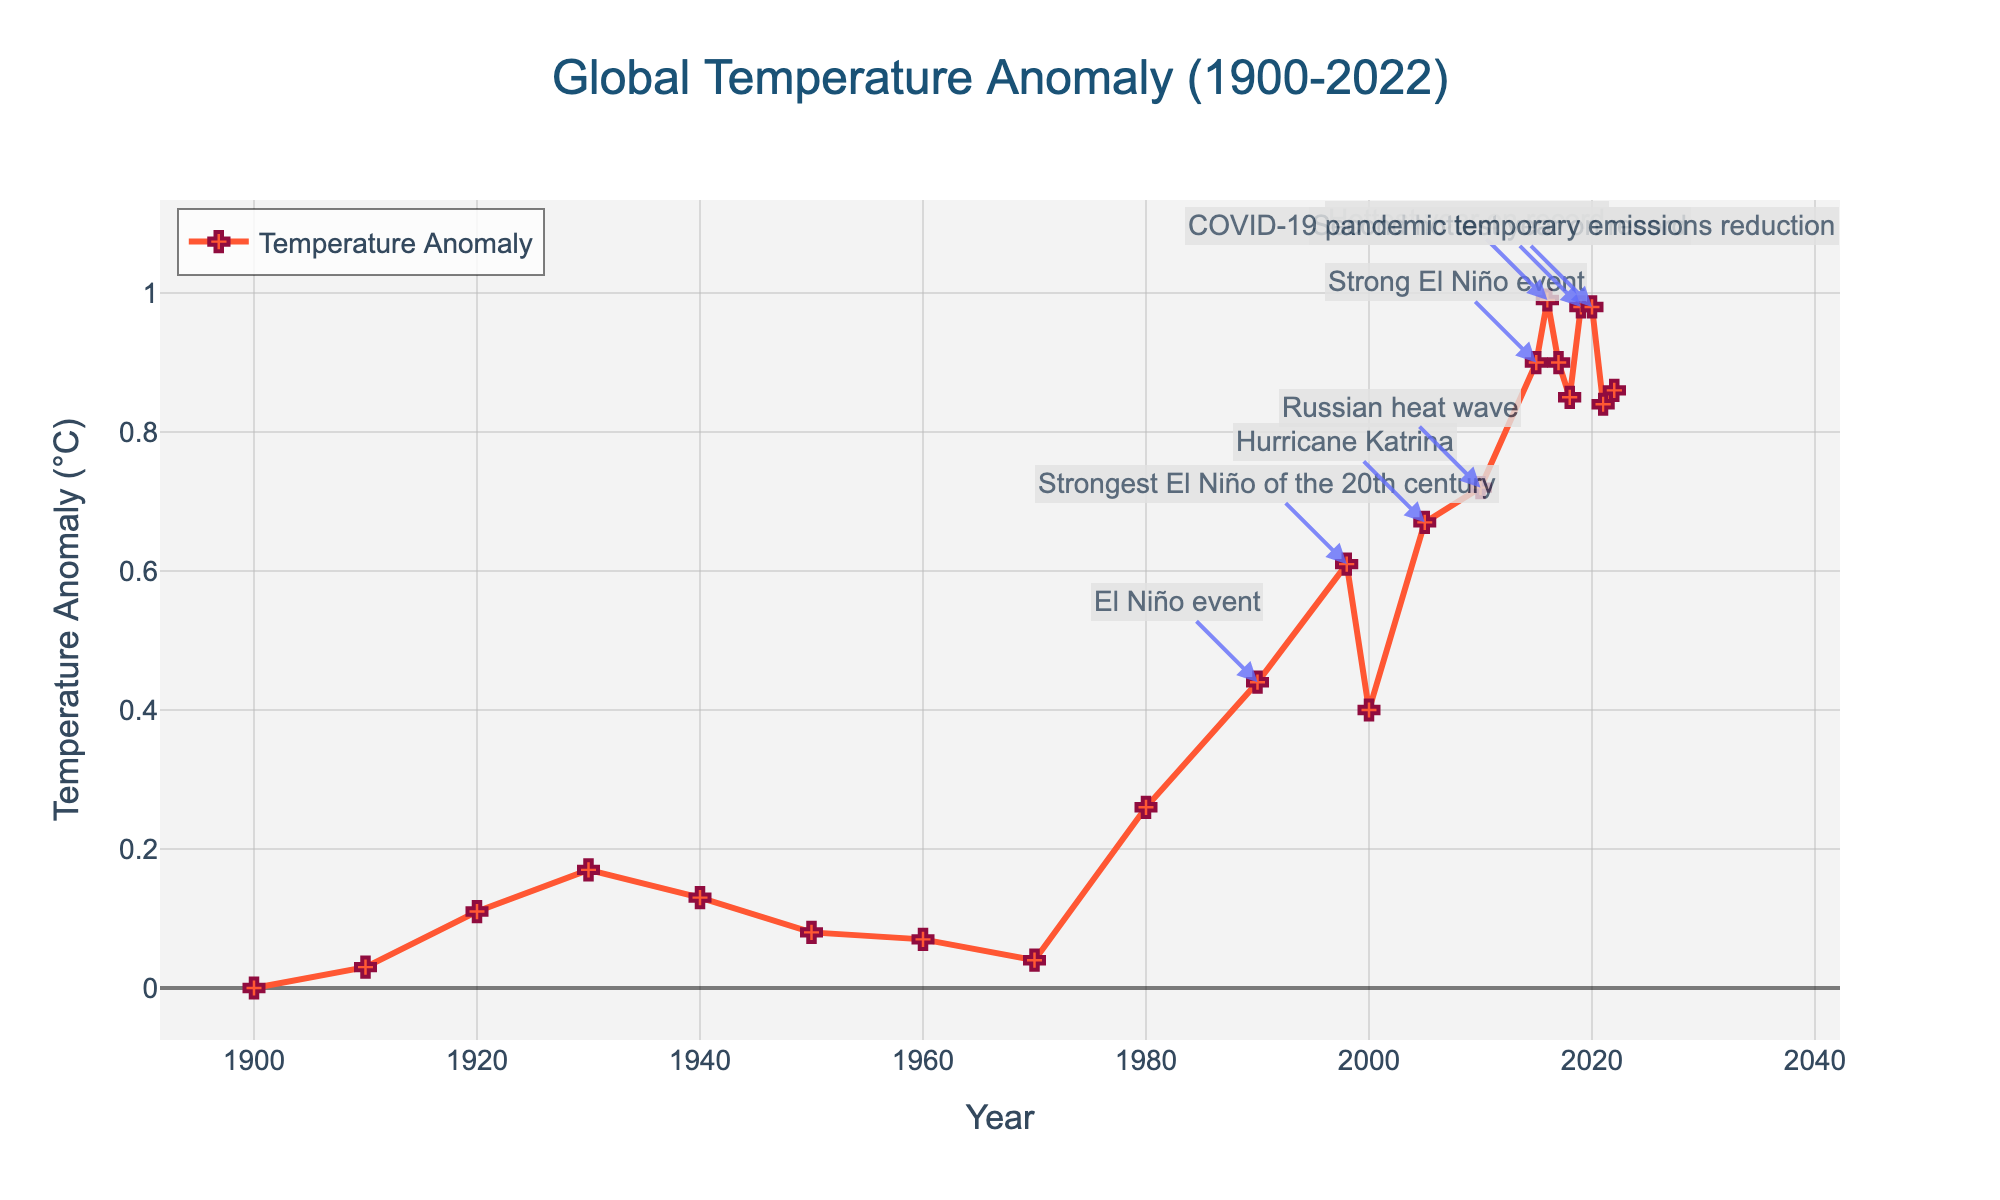What was the Global Temperature Anomaly in 2016? Look at the data point annotating 2016 on the line chart. The anomaly is marked on the y-axis as 0.99°C.
Answer: 0.99°C Which year had a stronger El Niño event: 1998 or 2015? Compare the annotation labels for El Niño events in 1998 and 2015. In 1998, it's labeled as the "Strongest El Niño of the 20th century", implying it was stronger than the "Strong El Niño event" in 2015.
Answer: 1998 What is the difference in Global Temperature Anomaly between the years 1900 and 2020? Subtract the anomaly of 1900 (0.00°C) from that of 2020 (0.98°C). 0.98°C - 0.00°C = 0.98°C
Answer: 0.98°C By how much did the Global Temperature Anomaly change from 2000 to 2005? Subtract the anomaly of 2000 (0.40°C) from that of 2005 (0.67°C). 0.67°C - 0.40°C = 0.27°C
Answer: 0.27°C In which decade did the Global Temperature Anomaly first exceed 0.5°C? Examine decade-by-decade data points and identify the earliest decade where the anomaly exceeds 0.5°C. This first happens in the 1990s (precisely in 1998).
Answer: 1990s List all years where a specific climate event is annotated and state the Global Temperature Anomaly for each. Look at the years with annotations: 1990 (0.44°C), 1998 (0.61°C), 2005 (0.67°C), 2010 (0.72°C), 2015 (0.90°C), 2016 (0.99°C), 2019 (0.98°C), 2020 (0.98°C).
Answer: 1990 (0.44°C), 1998 (0.61°C), 2005 (0.67°C), 2010 (0.72°C), 2015 (0.90°C), 2016 (0.99°C), 2019 (0.98°C), 2020 (0.98°C) What is the average Global Temperature Anomaly from 2015 to 2022? Average the anomalies for each year from 2015 to 2022: (0.90 + 0.99 + 0.90 + 0.85 + 0.98 + 0.98 + 0.84 + 0.86) / 8 = 0.90°C
Answer: 0.90°C How many years had anomalies greater than 0.70°C? Count the number of years where the Global Temperature Anomaly is above 0.70°C: 2010 (0.72°C), 2015 (0.90°C), 2016 (0.99°C), 2017 (0.90°C), 2019 (0.98°C), 2020 (0.98°C). Thus, there are 6 years.
Answer: 6 Which year was hotter: 2019 or 2021? Compare the Global Temperature Anomalies for the two years. 2019 had an anomaly of 0.98°C, while 2021 had 0.84°C. Therefore, 2019 was hotter.
Answer: 2019 